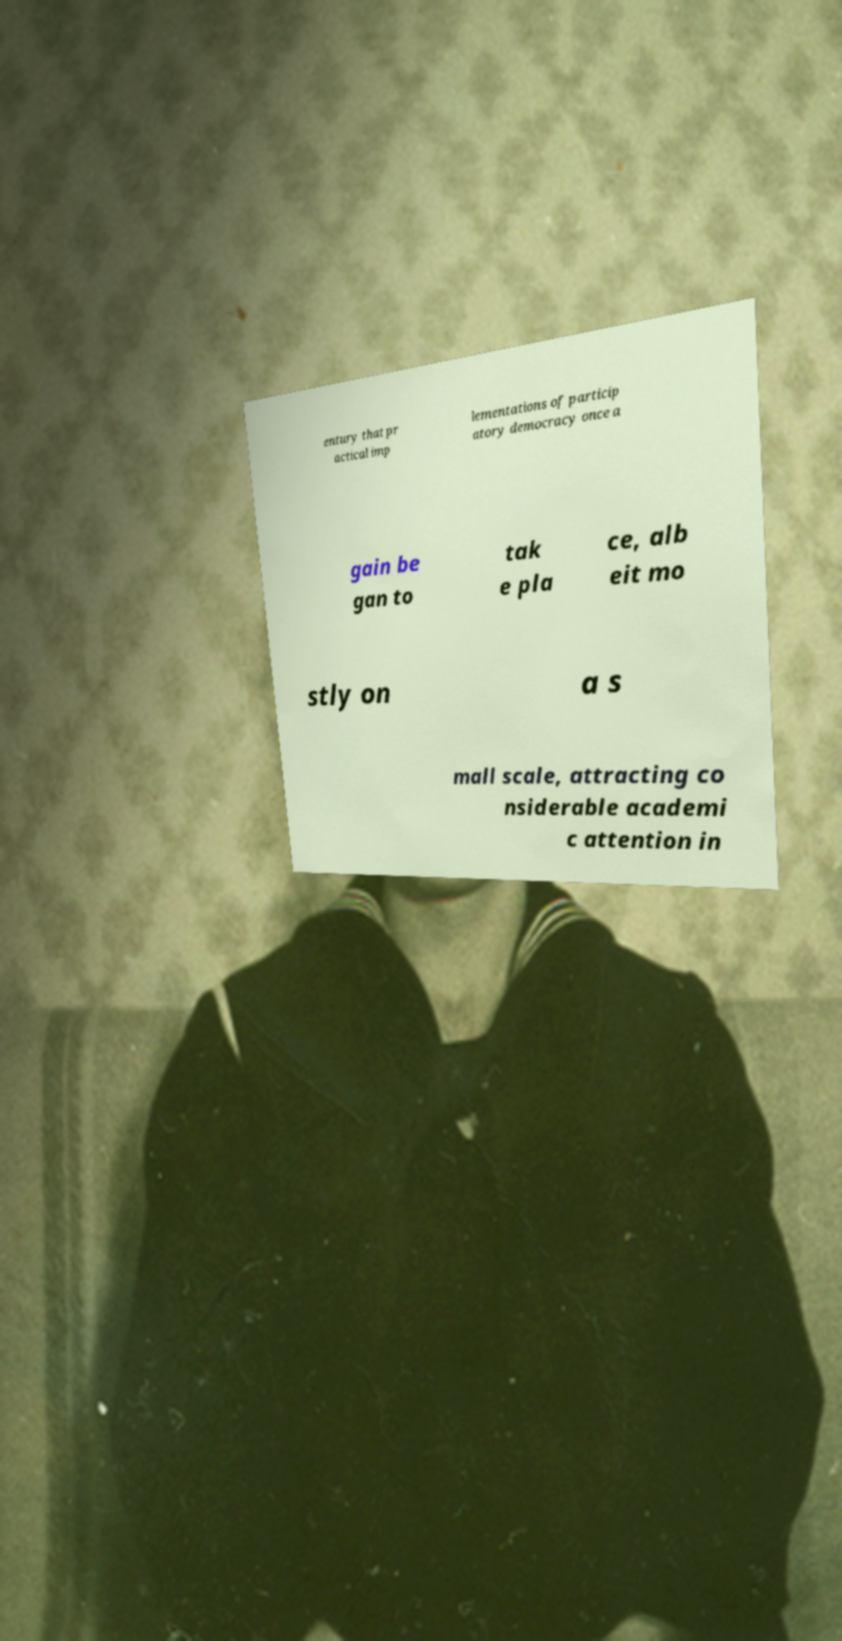Could you extract and type out the text from this image? entury that pr actical imp lementations of particip atory democracy once a gain be gan to tak e pla ce, alb eit mo stly on a s mall scale, attracting co nsiderable academi c attention in 